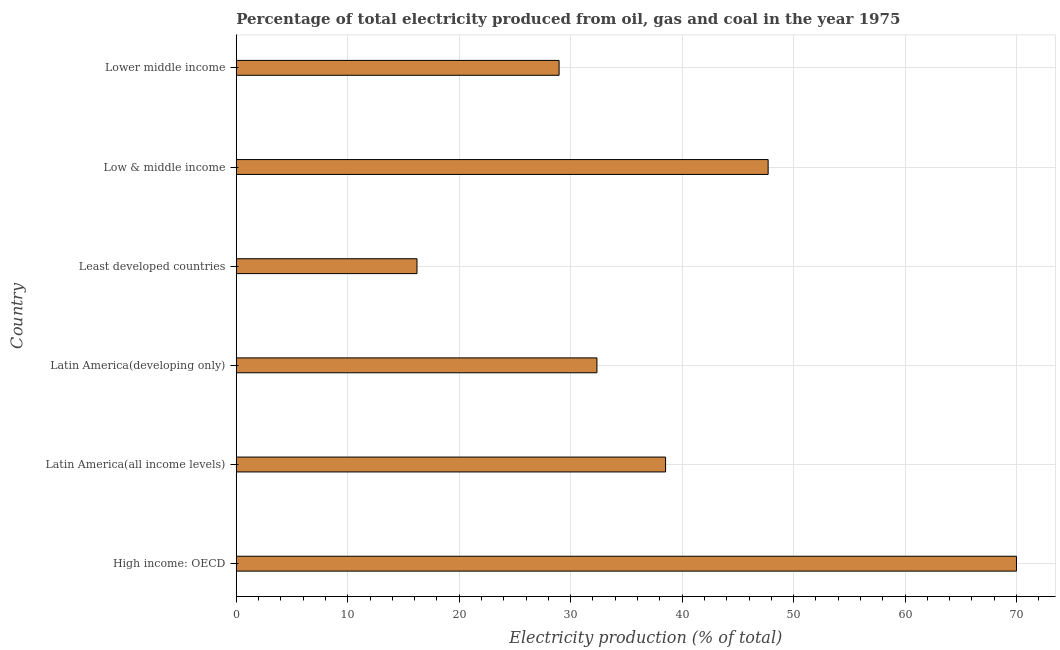Does the graph contain any zero values?
Offer a terse response. No. Does the graph contain grids?
Provide a succinct answer. Yes. What is the title of the graph?
Make the answer very short. Percentage of total electricity produced from oil, gas and coal in the year 1975. What is the label or title of the X-axis?
Provide a short and direct response. Electricity production (% of total). What is the electricity production in Latin America(all income levels)?
Your response must be concise. 38.52. Across all countries, what is the maximum electricity production?
Provide a succinct answer. 69.99. Across all countries, what is the minimum electricity production?
Offer a terse response. 16.21. In which country was the electricity production maximum?
Provide a succinct answer. High income: OECD. In which country was the electricity production minimum?
Make the answer very short. Least developed countries. What is the sum of the electricity production?
Make the answer very short. 233.76. What is the difference between the electricity production in High income: OECD and Lower middle income?
Your answer should be compact. 41.03. What is the average electricity production per country?
Your response must be concise. 38.96. What is the median electricity production?
Offer a terse response. 35.44. What is the ratio of the electricity production in Latin America(developing only) to that in Low & middle income?
Your response must be concise. 0.68. Is the difference between the electricity production in Latin America(all income levels) and Least developed countries greater than the difference between any two countries?
Offer a very short reply. No. What is the difference between the highest and the second highest electricity production?
Your answer should be compact. 22.28. Is the sum of the electricity production in Latin America(all income levels) and Lower middle income greater than the maximum electricity production across all countries?
Provide a succinct answer. No. What is the difference between the highest and the lowest electricity production?
Give a very brief answer. 53.78. In how many countries, is the electricity production greater than the average electricity production taken over all countries?
Ensure brevity in your answer.  2. Are all the bars in the graph horizontal?
Provide a succinct answer. Yes. How many countries are there in the graph?
Provide a short and direct response. 6. What is the difference between two consecutive major ticks on the X-axis?
Provide a short and direct response. 10. What is the Electricity production (% of total) in High income: OECD?
Provide a succinct answer. 69.99. What is the Electricity production (% of total) in Latin America(all income levels)?
Offer a terse response. 38.52. What is the Electricity production (% of total) in Latin America(developing only)?
Offer a terse response. 32.36. What is the Electricity production (% of total) in Least developed countries?
Offer a very short reply. 16.21. What is the Electricity production (% of total) of Low & middle income?
Ensure brevity in your answer.  47.72. What is the Electricity production (% of total) in Lower middle income?
Your answer should be compact. 28.96. What is the difference between the Electricity production (% of total) in High income: OECD and Latin America(all income levels)?
Your answer should be compact. 31.48. What is the difference between the Electricity production (% of total) in High income: OECD and Latin America(developing only)?
Ensure brevity in your answer.  37.64. What is the difference between the Electricity production (% of total) in High income: OECD and Least developed countries?
Provide a short and direct response. 53.78. What is the difference between the Electricity production (% of total) in High income: OECD and Low & middle income?
Provide a short and direct response. 22.28. What is the difference between the Electricity production (% of total) in High income: OECD and Lower middle income?
Provide a succinct answer. 41.03. What is the difference between the Electricity production (% of total) in Latin America(all income levels) and Latin America(developing only)?
Make the answer very short. 6.16. What is the difference between the Electricity production (% of total) in Latin America(all income levels) and Least developed countries?
Offer a very short reply. 22.3. What is the difference between the Electricity production (% of total) in Latin America(all income levels) and Low & middle income?
Provide a short and direct response. -9.2. What is the difference between the Electricity production (% of total) in Latin America(all income levels) and Lower middle income?
Provide a short and direct response. 9.55. What is the difference between the Electricity production (% of total) in Latin America(developing only) and Least developed countries?
Offer a terse response. 16.14. What is the difference between the Electricity production (% of total) in Latin America(developing only) and Low & middle income?
Offer a very short reply. -15.36. What is the difference between the Electricity production (% of total) in Latin America(developing only) and Lower middle income?
Give a very brief answer. 3.4. What is the difference between the Electricity production (% of total) in Least developed countries and Low & middle income?
Your answer should be very brief. -31.5. What is the difference between the Electricity production (% of total) in Least developed countries and Lower middle income?
Give a very brief answer. -12.75. What is the difference between the Electricity production (% of total) in Low & middle income and Lower middle income?
Give a very brief answer. 18.75. What is the ratio of the Electricity production (% of total) in High income: OECD to that in Latin America(all income levels)?
Keep it short and to the point. 1.82. What is the ratio of the Electricity production (% of total) in High income: OECD to that in Latin America(developing only)?
Ensure brevity in your answer.  2.16. What is the ratio of the Electricity production (% of total) in High income: OECD to that in Least developed countries?
Offer a terse response. 4.32. What is the ratio of the Electricity production (% of total) in High income: OECD to that in Low & middle income?
Provide a short and direct response. 1.47. What is the ratio of the Electricity production (% of total) in High income: OECD to that in Lower middle income?
Your response must be concise. 2.42. What is the ratio of the Electricity production (% of total) in Latin America(all income levels) to that in Latin America(developing only)?
Offer a very short reply. 1.19. What is the ratio of the Electricity production (% of total) in Latin America(all income levels) to that in Least developed countries?
Offer a terse response. 2.38. What is the ratio of the Electricity production (% of total) in Latin America(all income levels) to that in Low & middle income?
Provide a succinct answer. 0.81. What is the ratio of the Electricity production (% of total) in Latin America(all income levels) to that in Lower middle income?
Provide a succinct answer. 1.33. What is the ratio of the Electricity production (% of total) in Latin America(developing only) to that in Least developed countries?
Your answer should be compact. 2. What is the ratio of the Electricity production (% of total) in Latin America(developing only) to that in Low & middle income?
Give a very brief answer. 0.68. What is the ratio of the Electricity production (% of total) in Latin America(developing only) to that in Lower middle income?
Offer a terse response. 1.12. What is the ratio of the Electricity production (% of total) in Least developed countries to that in Low & middle income?
Give a very brief answer. 0.34. What is the ratio of the Electricity production (% of total) in Least developed countries to that in Lower middle income?
Ensure brevity in your answer.  0.56. What is the ratio of the Electricity production (% of total) in Low & middle income to that in Lower middle income?
Make the answer very short. 1.65. 